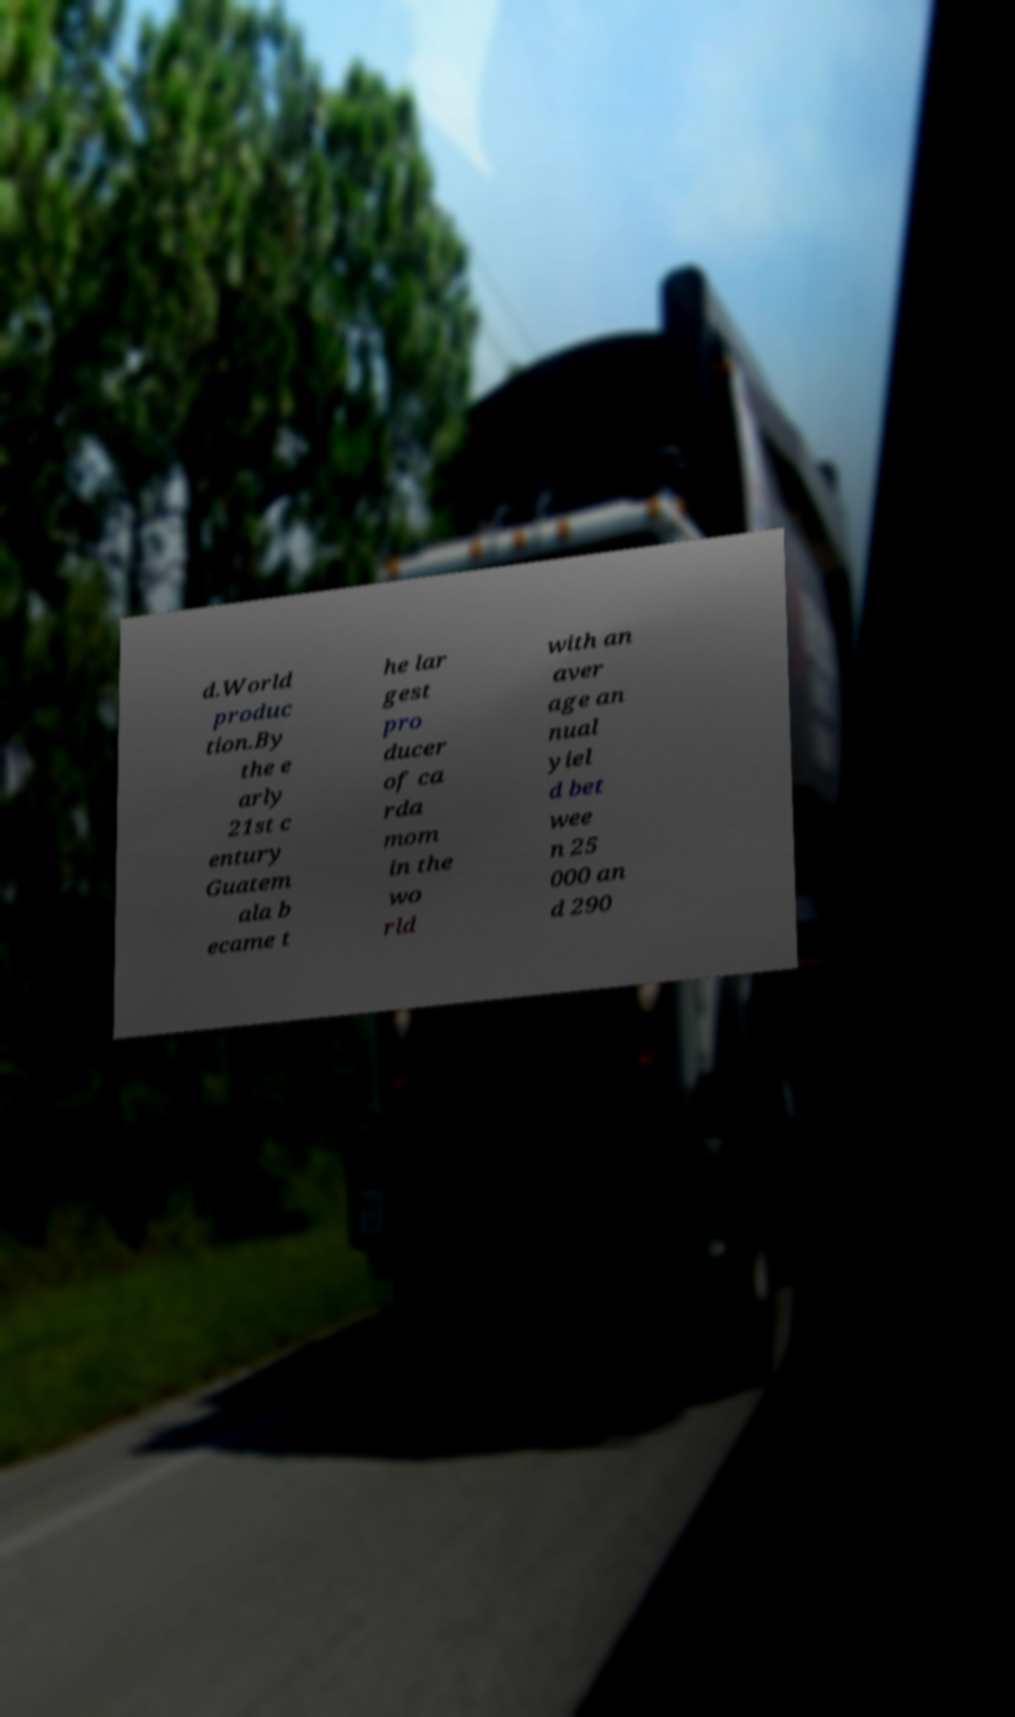What messages or text are displayed in this image? I need them in a readable, typed format. d.World produc tion.By the e arly 21st c entury Guatem ala b ecame t he lar gest pro ducer of ca rda mom in the wo rld with an aver age an nual yiel d bet wee n 25 000 an d 290 